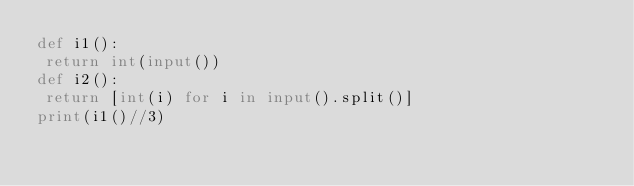Convert code to text. <code><loc_0><loc_0><loc_500><loc_500><_Python_>def i1():
 return int(input())
def i2():
 return [int(i) for i in input().split()]
print(i1()//3)</code> 